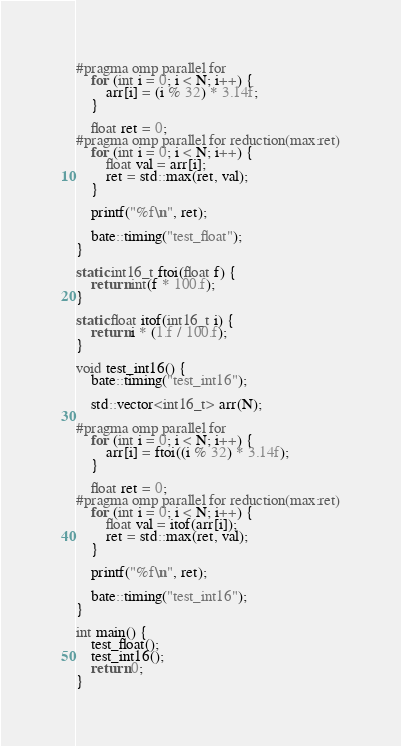<code> <loc_0><loc_0><loc_500><loc_500><_C++_>#pragma omp parallel for
    for (int i = 0; i < N; i++) {
        arr[i] = (i % 32) * 3.14f;
    }

    float ret = 0;
#pragma omp parallel for reduction(max:ret)
    for (int i = 0; i < N; i++) {
        float val = arr[i];
        ret = std::max(ret, val);
    }

    printf("%f\n", ret);

    bate::timing("test_float");
}

static int16_t ftoi(float f) {
    return int(f * 100.f);
}

static float itof(int16_t i) {
    return i * (1.f / 100.f);
}

void test_int16() {
    bate::timing("test_int16");

    std::vector<int16_t> arr(N);

#pragma omp parallel for
    for (int i = 0; i < N; i++) {
        arr[i] = ftoi((i % 32) * 3.14f);
    }

    float ret = 0;
#pragma omp parallel for reduction(max:ret)
    for (int i = 0; i < N; i++) {
        float val = itof(arr[i]);
        ret = std::max(ret, val);
    }

    printf("%f\n", ret);

    bate::timing("test_int16");
}

int main() {
    test_float();
    test_int16();
    return 0;
}
</code> 